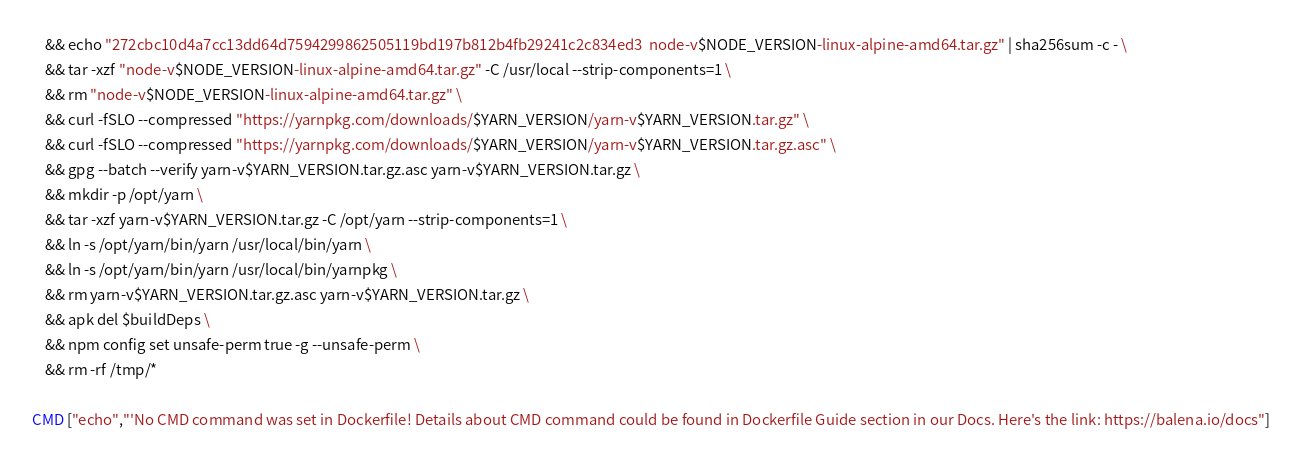Convert code to text. <code><loc_0><loc_0><loc_500><loc_500><_Dockerfile_>	&& echo "272cbc10d4a7cc13dd64d7594299862505119bd197b812b4fb29241c2c834ed3  node-v$NODE_VERSION-linux-alpine-amd64.tar.gz" | sha256sum -c - \
	&& tar -xzf "node-v$NODE_VERSION-linux-alpine-amd64.tar.gz" -C /usr/local --strip-components=1 \
	&& rm "node-v$NODE_VERSION-linux-alpine-amd64.tar.gz" \
	&& curl -fSLO --compressed "https://yarnpkg.com/downloads/$YARN_VERSION/yarn-v$YARN_VERSION.tar.gz" \
	&& curl -fSLO --compressed "https://yarnpkg.com/downloads/$YARN_VERSION/yarn-v$YARN_VERSION.tar.gz.asc" \
	&& gpg --batch --verify yarn-v$YARN_VERSION.tar.gz.asc yarn-v$YARN_VERSION.tar.gz \
	&& mkdir -p /opt/yarn \
	&& tar -xzf yarn-v$YARN_VERSION.tar.gz -C /opt/yarn --strip-components=1 \
	&& ln -s /opt/yarn/bin/yarn /usr/local/bin/yarn \
	&& ln -s /opt/yarn/bin/yarn /usr/local/bin/yarnpkg \
	&& rm yarn-v$YARN_VERSION.tar.gz.asc yarn-v$YARN_VERSION.tar.gz \
	&& apk del $buildDeps \
	&& npm config set unsafe-perm true -g --unsafe-perm \
	&& rm -rf /tmp/*

CMD ["echo","'No CMD command was set in Dockerfile! Details about CMD command could be found in Dockerfile Guide section in our Docs. Here's the link: https://balena.io/docs"]</code> 